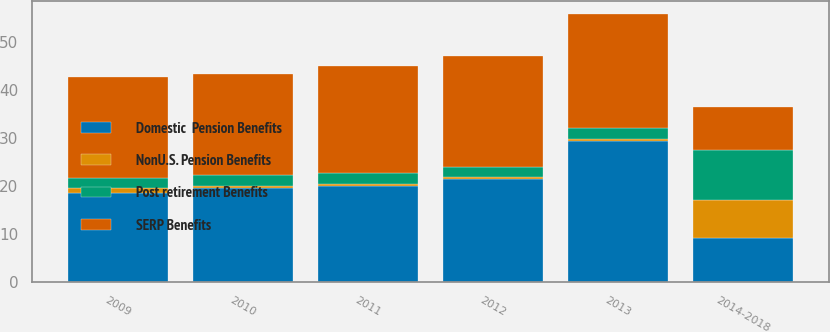Convert chart to OTSL. <chart><loc_0><loc_0><loc_500><loc_500><stacked_bar_chart><ecel><fcel>2009<fcel>2010<fcel>2011<fcel>2012<fcel>2013<fcel>2014-2018<nl><fcel>SERP Benefits<fcel>21<fcel>21.3<fcel>22.4<fcel>23.2<fcel>23.8<fcel>9.15<nl><fcel>Domestic  Pension Benefits<fcel>18.5<fcel>19.5<fcel>20<fcel>21.4<fcel>29.4<fcel>9.15<nl><fcel>NonU.S. Pension Benefits<fcel>1<fcel>0.5<fcel>0.5<fcel>0.5<fcel>0.5<fcel>8<nl><fcel>Post retirement Benefits<fcel>2.2<fcel>2.2<fcel>2.2<fcel>2.1<fcel>2.2<fcel>10.3<nl></chart> 